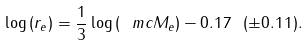Convert formula to latex. <formula><loc_0><loc_0><loc_500><loc_500>\log { ( r _ { e } ) } = \frac { 1 } { 3 } \log { ( \ m c { M } _ { e } ) } - 0 . 1 7 \ ( \pm 0 . 1 1 ) .</formula> 